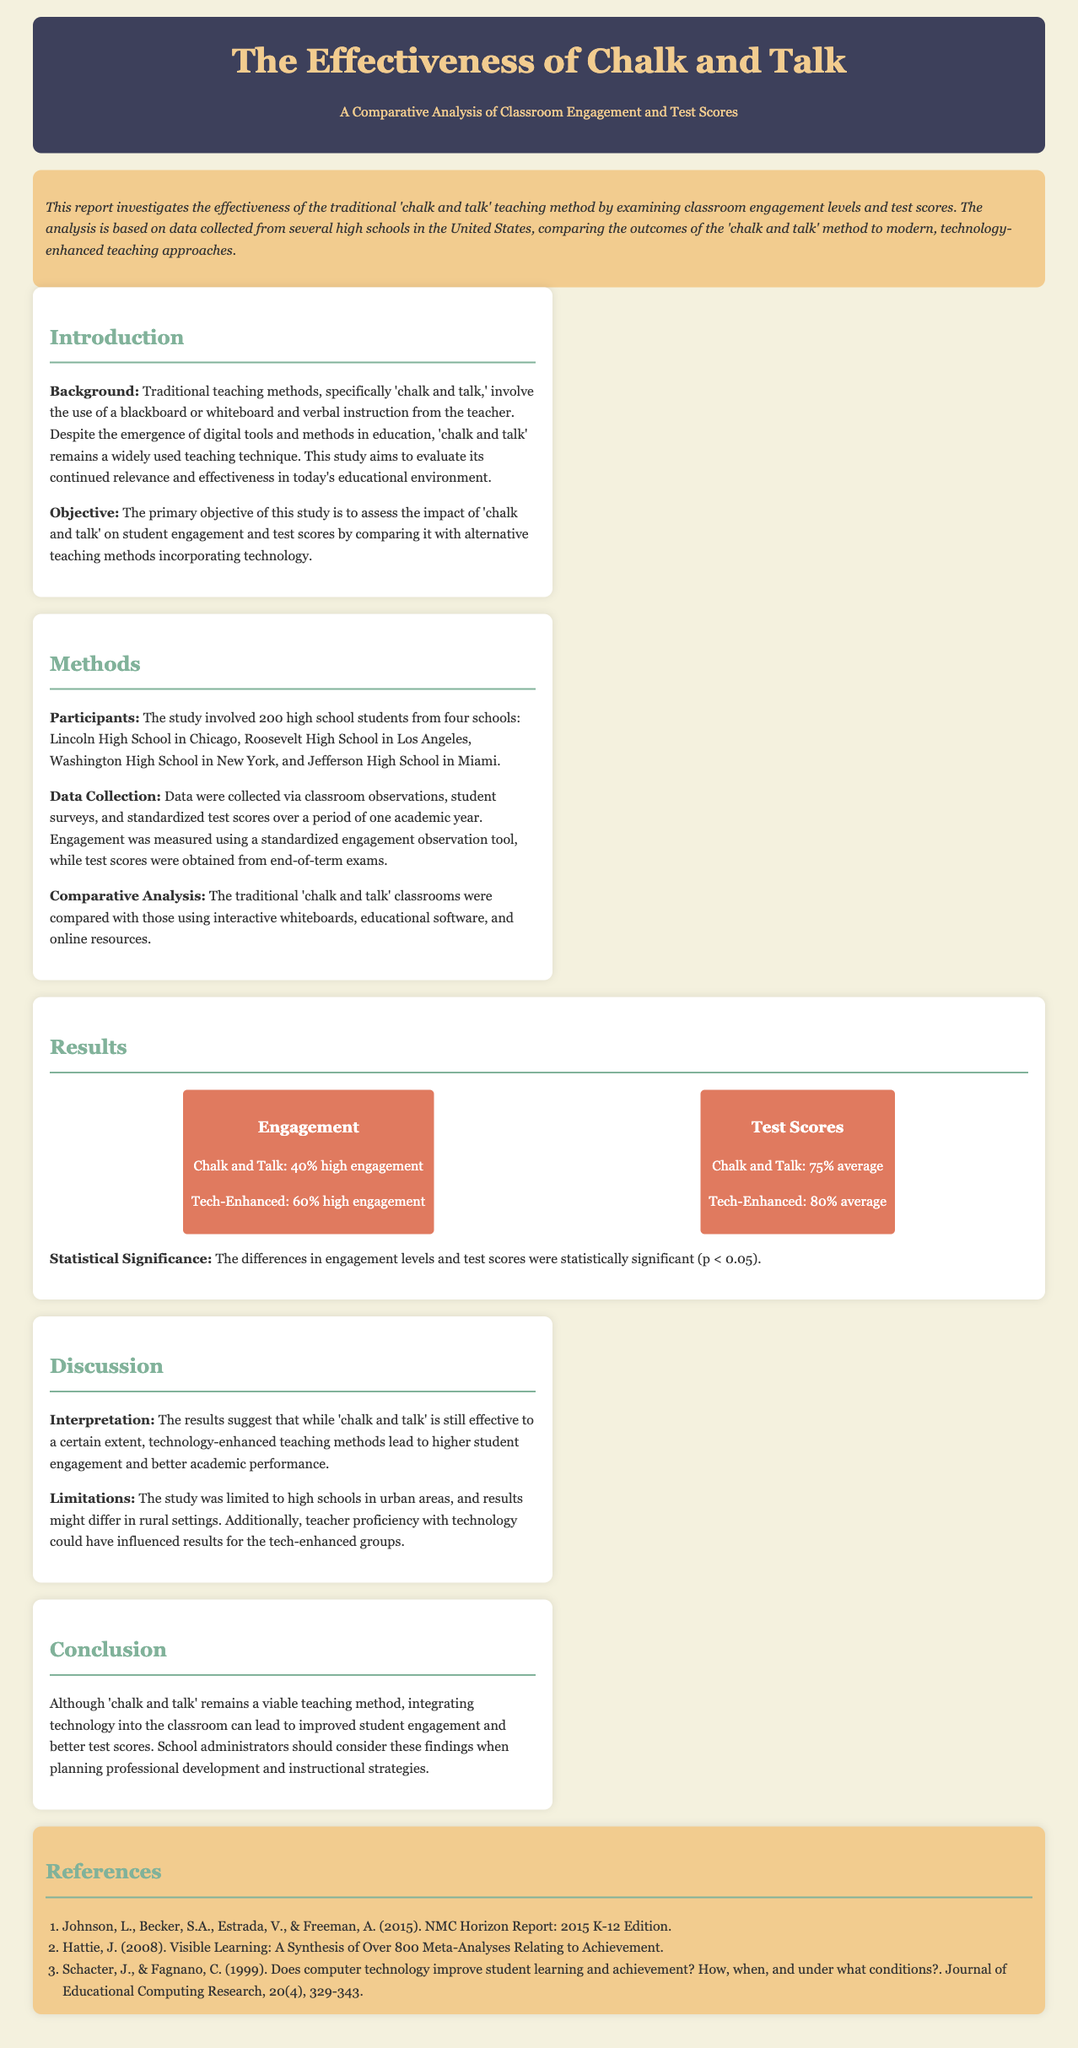What is the main teaching method being analyzed? The main teaching method being analyzed is 'chalk and talk,' a traditional instructional technique.
Answer: chalk and talk What percentage of high engagement was noted for tech-enhanced classrooms? The document states that 60% high engagement was noted for tech-enhanced classrooms compared to traditional methods.
Answer: 60% How many high schools participated in the study? The study involved a total of four high schools across different cities in the United States.
Answer: four What is the average test score for 'chalk and talk' classrooms? The average test score for 'chalk and talk' classrooms as stated in the report is 75%.
Answer: 75% What was the statistical significance threshold reported? The report mentions that the differences observed in engagement levels and test scores were statistically significant at p < 0.05.
Answer: p < 0.05 What type of analysis was performed in this study? The analysis conducted was a comparative analysis between traditional and technology-enhanced teaching methods.
Answer: comparative analysis Which city is associated with Lincoln High School? Lincoln High School is located in Chicago, as per the participant details in the document.
Answer: Chicago What limitation is mentioned concerning the study's setting? The study's setting limitation is that it was confined to high schools in urban areas, indicating potential variability in rural settings.
Answer: urban areas What is the primary objective of the study? The primary objective of the study is to assess the impact of 'chalk and talk' on student engagement and test scores.
Answer: assess the impact of 'chalk and talk' on student engagement and test scores 